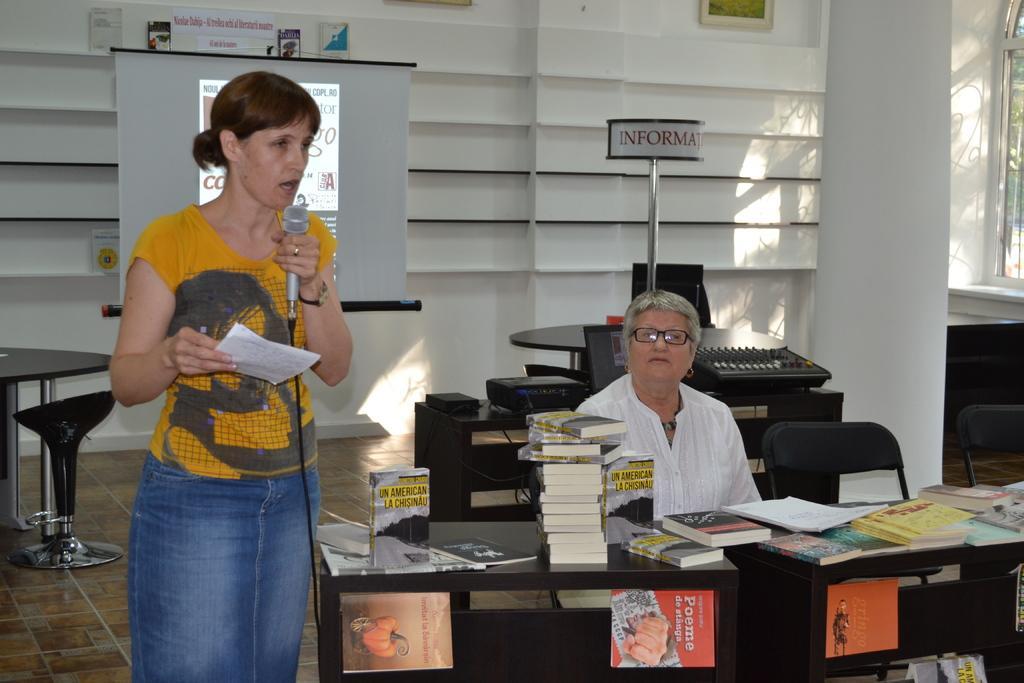In one or two sentences, can you explain what this image depicts? As we can see in the image, there are two people. the woman who is standing here is holding mic. In the background there is a wall and there is a table over here. On table there are books. 